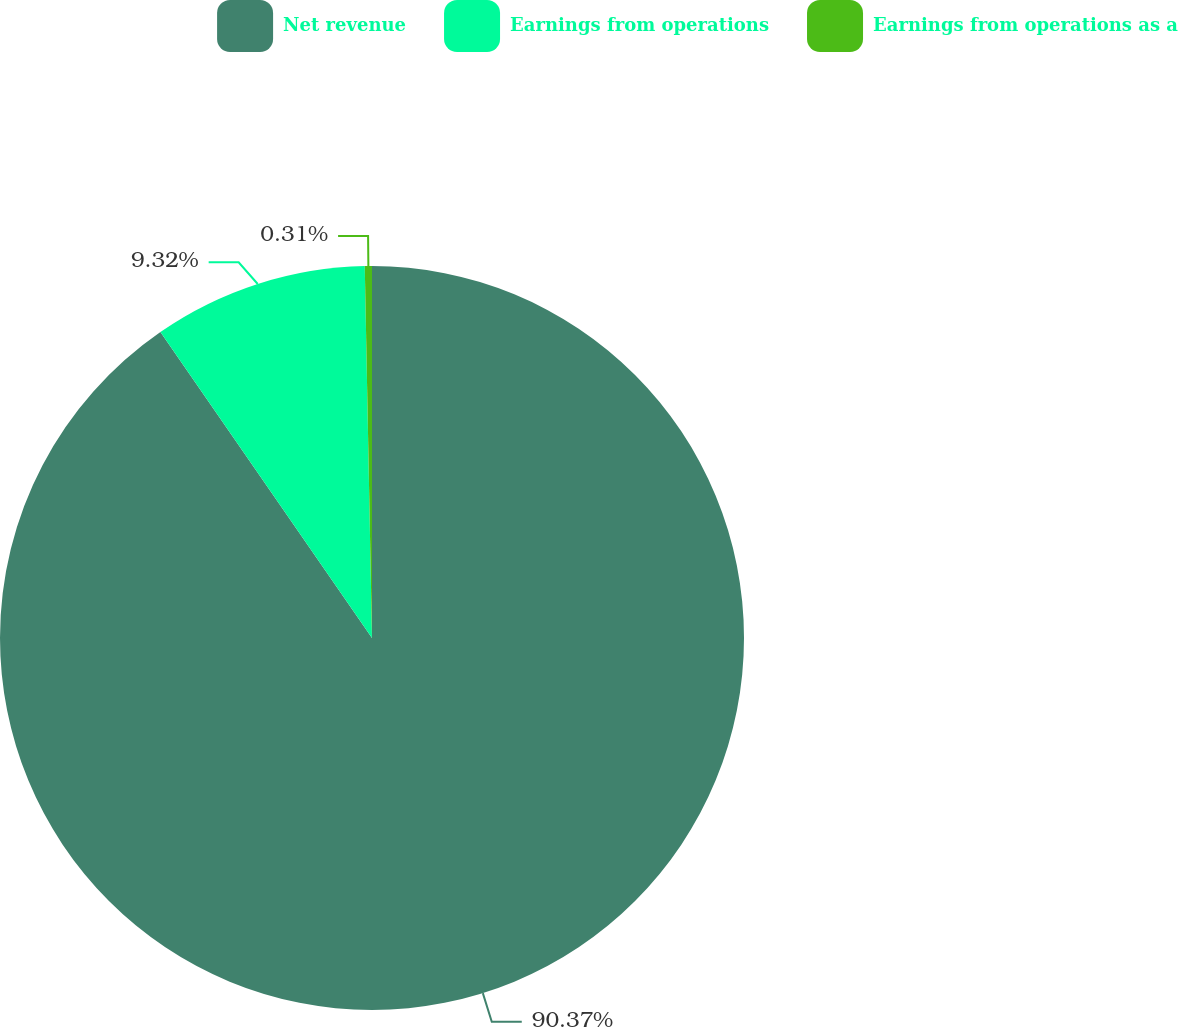Convert chart. <chart><loc_0><loc_0><loc_500><loc_500><pie_chart><fcel>Net revenue<fcel>Earnings from operations<fcel>Earnings from operations as a<nl><fcel>90.37%<fcel>9.32%<fcel>0.31%<nl></chart> 